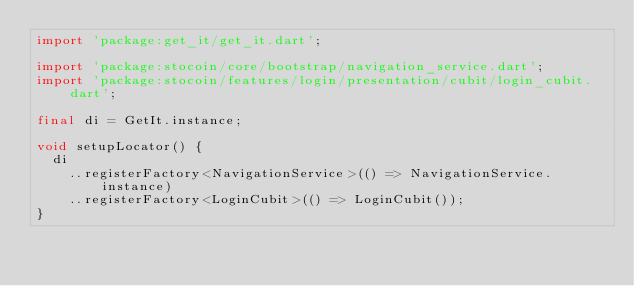<code> <loc_0><loc_0><loc_500><loc_500><_Dart_>import 'package:get_it/get_it.dart';

import 'package:stocoin/core/bootstrap/navigation_service.dart';
import 'package:stocoin/features/login/presentation/cubit/login_cubit.dart';

final di = GetIt.instance;

void setupLocator() {
  di
    ..registerFactory<NavigationService>(() => NavigationService.instance)
    ..registerFactory<LoginCubit>(() => LoginCubit());
}
</code> 